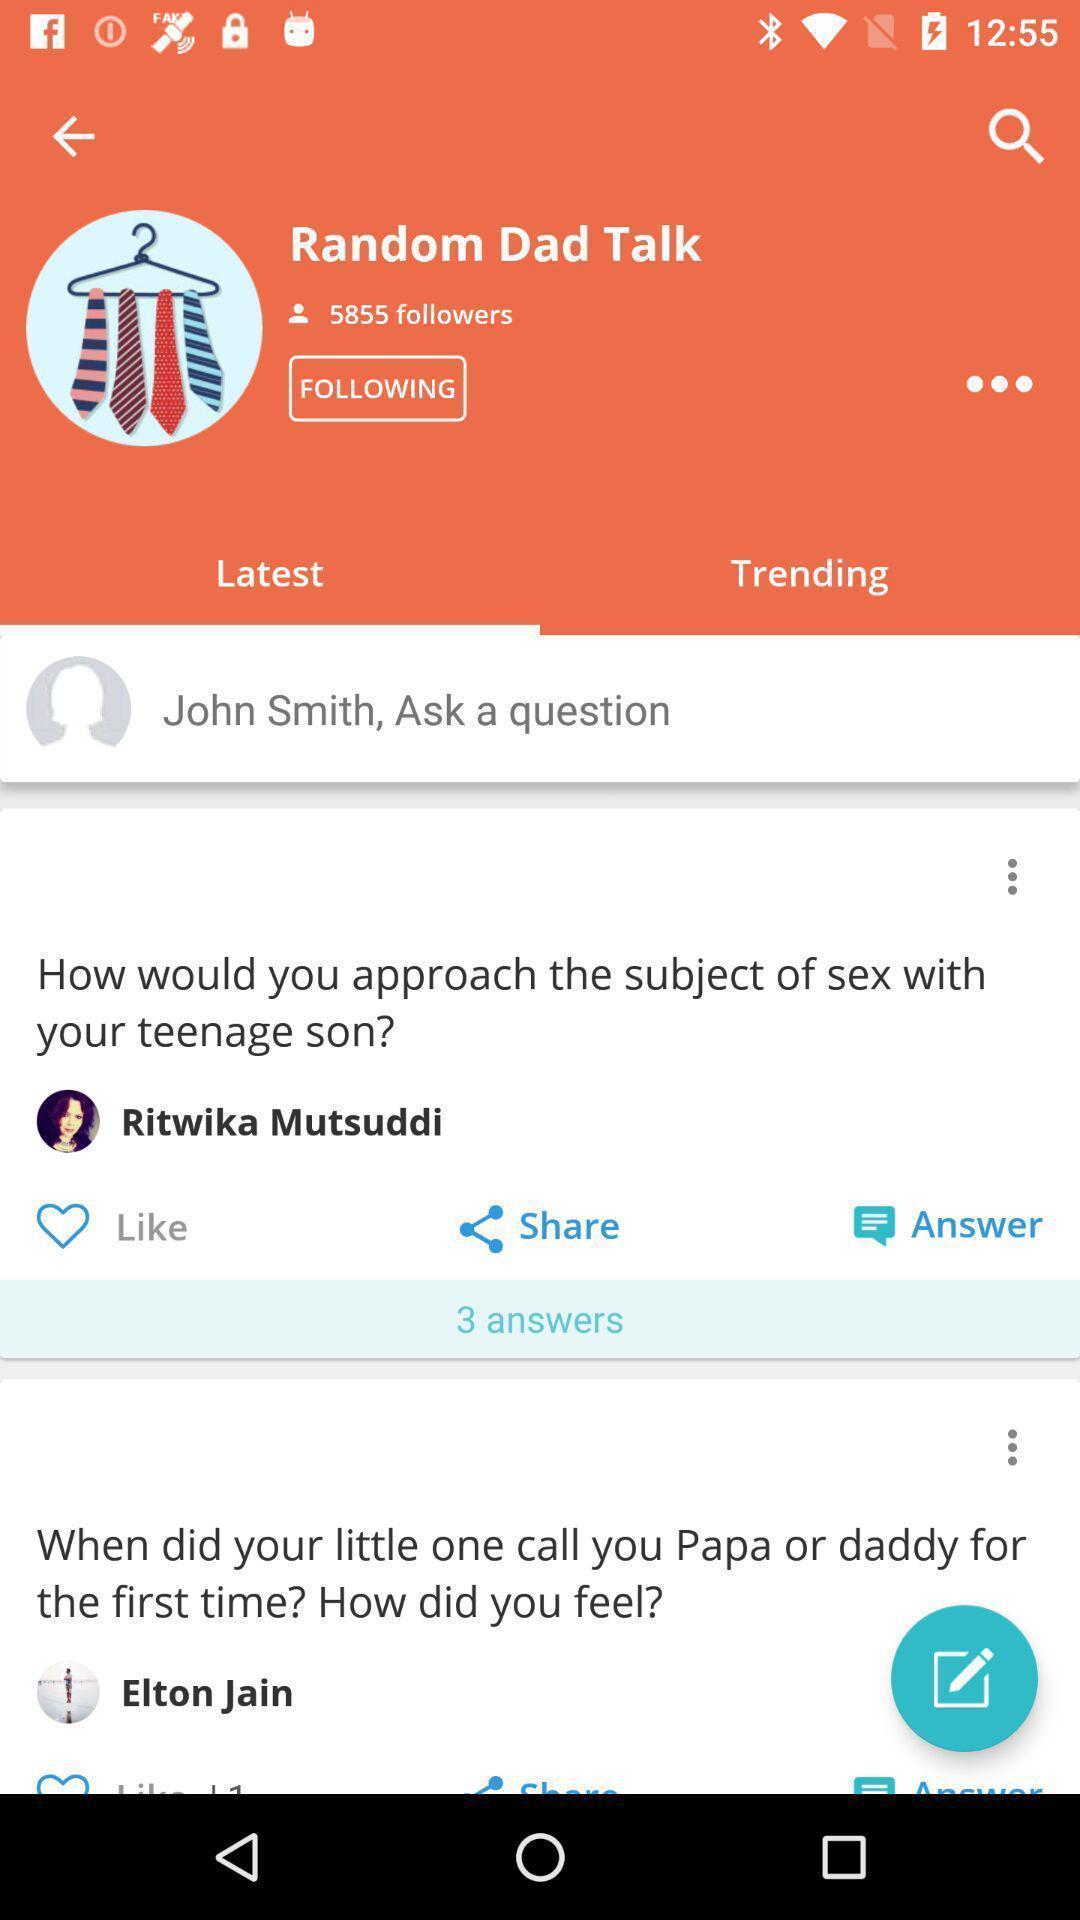Give me a summary of this screen capture. Page showing latest questions on app. 